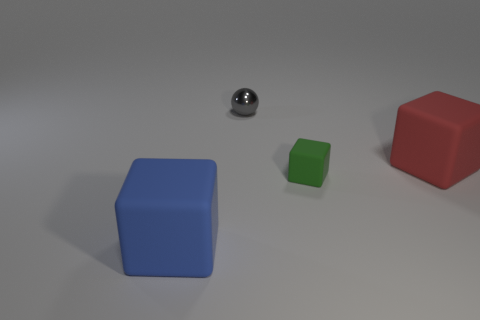Add 2 small gray metal objects. How many objects exist? 6 Subtract all blocks. How many objects are left? 1 Add 1 blue matte cubes. How many blue matte cubes are left? 2 Add 1 small gray metallic balls. How many small gray metallic balls exist? 2 Subtract 1 green cubes. How many objects are left? 3 Subtract all metal objects. Subtract all large blue blocks. How many objects are left? 2 